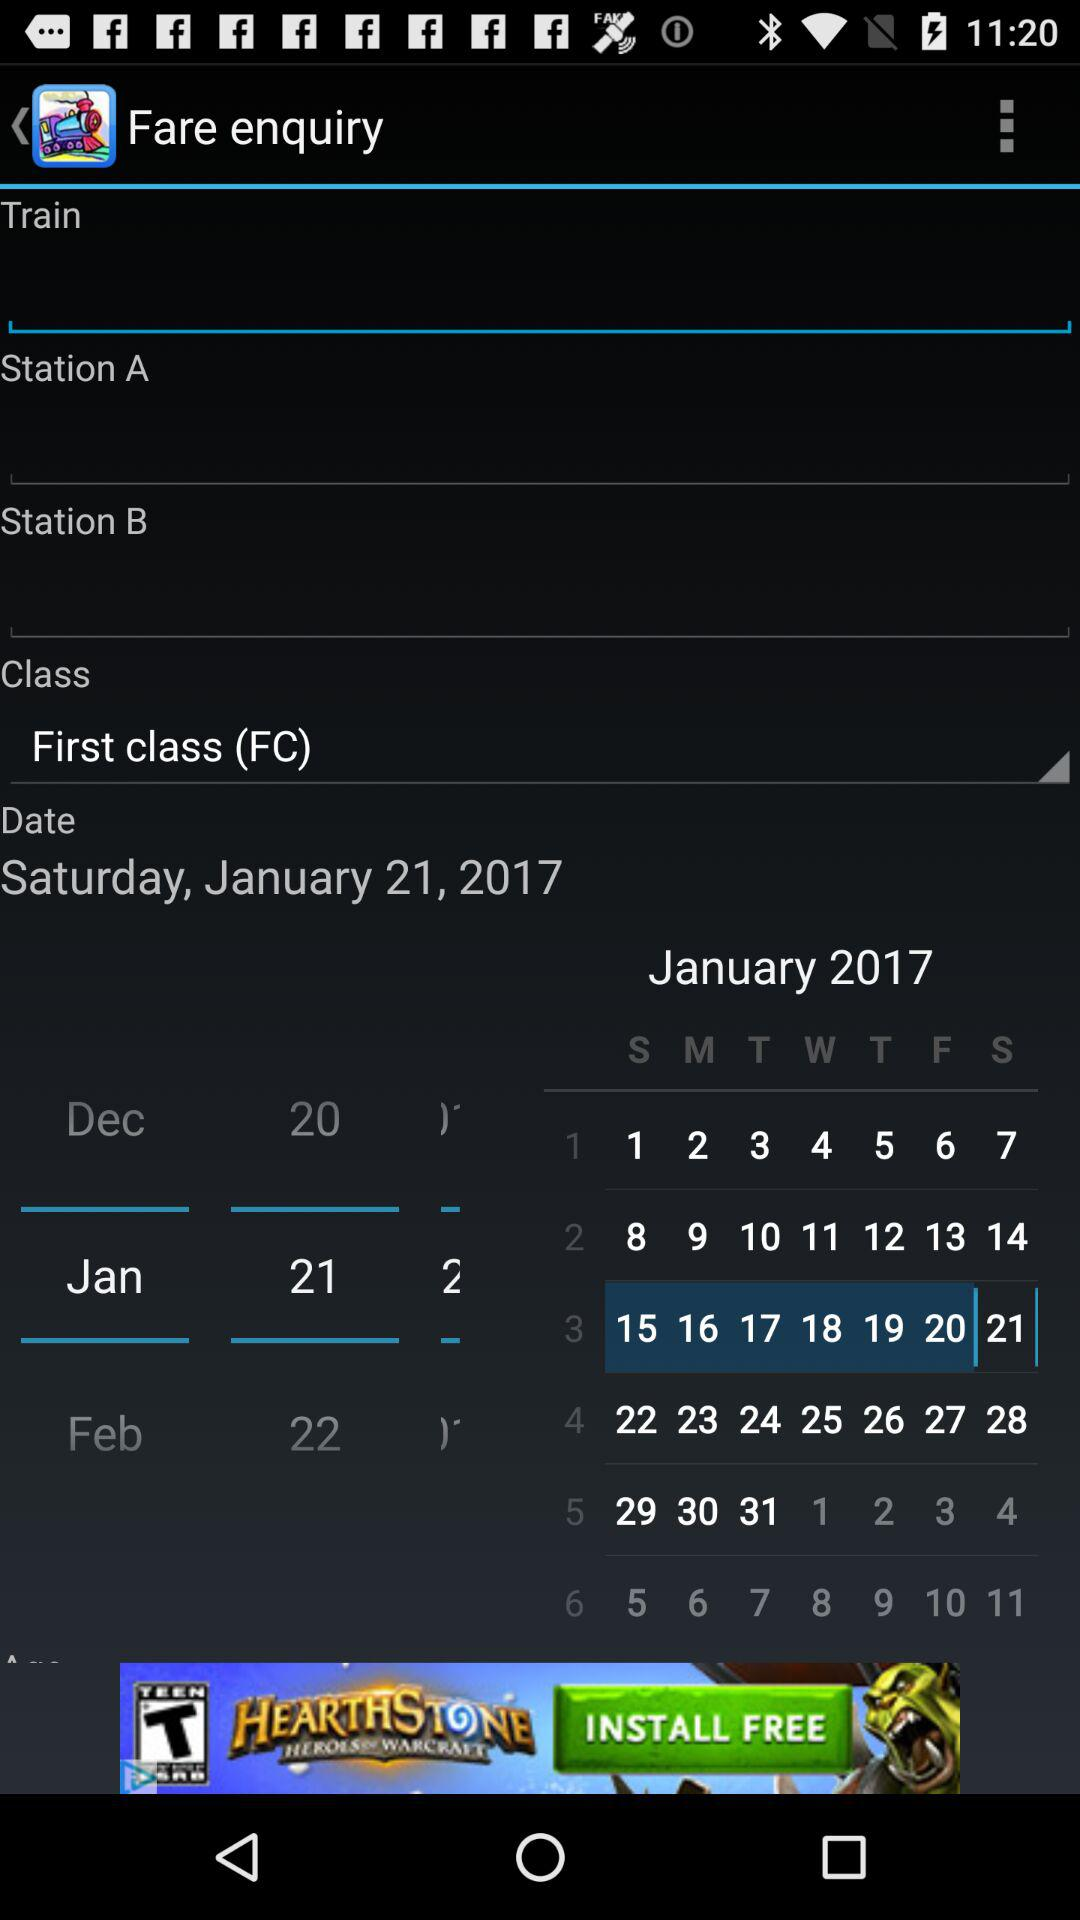What is the departure date? The departure date is Saturday, January 21, 2017. 